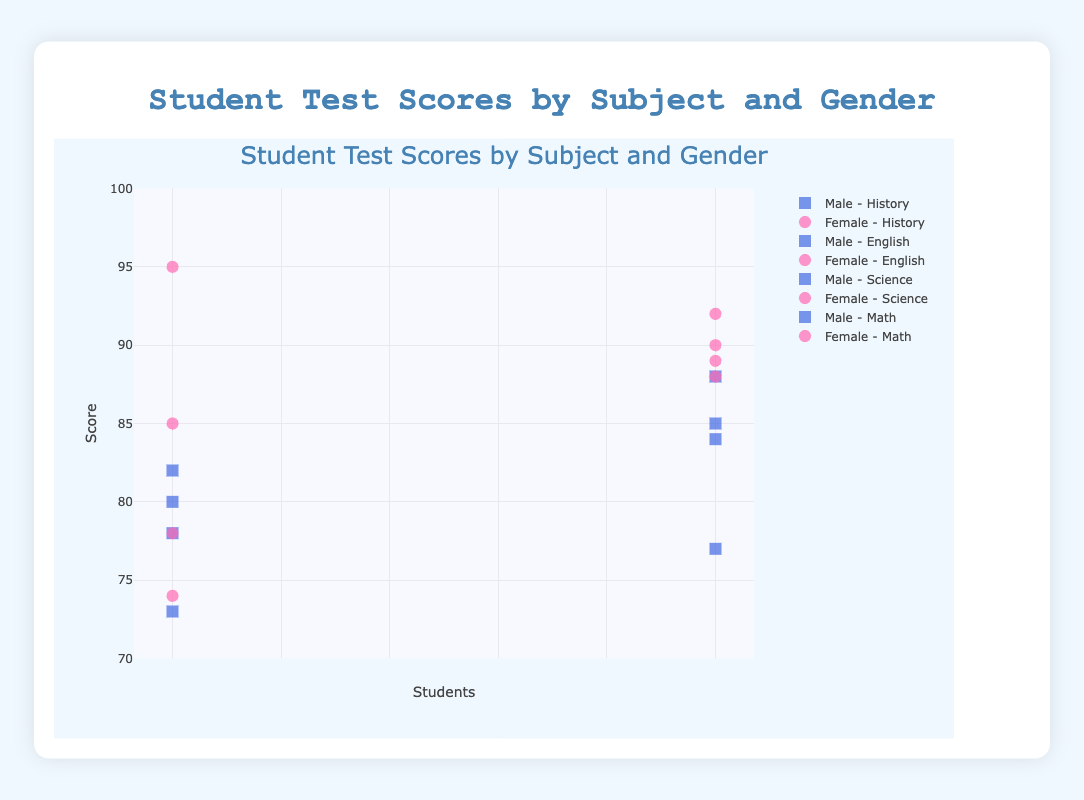What is the title of the plot? The title is located at the top of the plot and is displayed prominently in a larger font size for easy identification.
Answer: Student Test Scores by Subject and Gender How many data points are there for male students in Math? By looking at the markers (squares for males) in the math section of the plot, we can count the number of data points.
Answer: 2 Which gender has the highest score in Science? By comparing the highest points in the Science section, we see that the highest score is represented by a pink circle, which indicates a female student.
Answer: Female What is the range of the y-axis? The y-axis range is indicated by the labels on the y-axis, which typically show the minimum and maximum values.
Answer: 70 to 100 Among all subjects, which student has the lowest score and what is it? By identifying the lowest point in the entire plot, we can check the hover information to find the student's name and score.
Answer: Frank Moore (73) Which subject shows the greatest variation in scores? Variation can be observed by noting the spread of data points within each subject's section. The subject with the widest spread between the highest and lowest points has the greatest variation.
Answer: Science What is the average score for female students in English? Find the scores for female students in the English section and calculate the average: (74 + 90)/2 = 82
Answer: 82 Which subject has the highest average score for female students? Calculate the averages for female students in each subject and compare them: Math (85+92)/2=88.5, Science (95+89)/2=92, English (74+90)/2=82, History (78+88)/2=83.
Answer: Science How do the average scores of male and female students in Math compare? Calculate the averages and compare them: Male Math (78+88)/2=83, Female Math (85+92)/2=88.5. Therefore, females have a higher average score.
Answer: Females have a higher average score In which subject did the smallest gap between the highest and lowest scores occur among female students? By examining the vertical distance between markers in each subject's section for female students, the smallest gap is found in the subject with points closest together.
Answer: English 